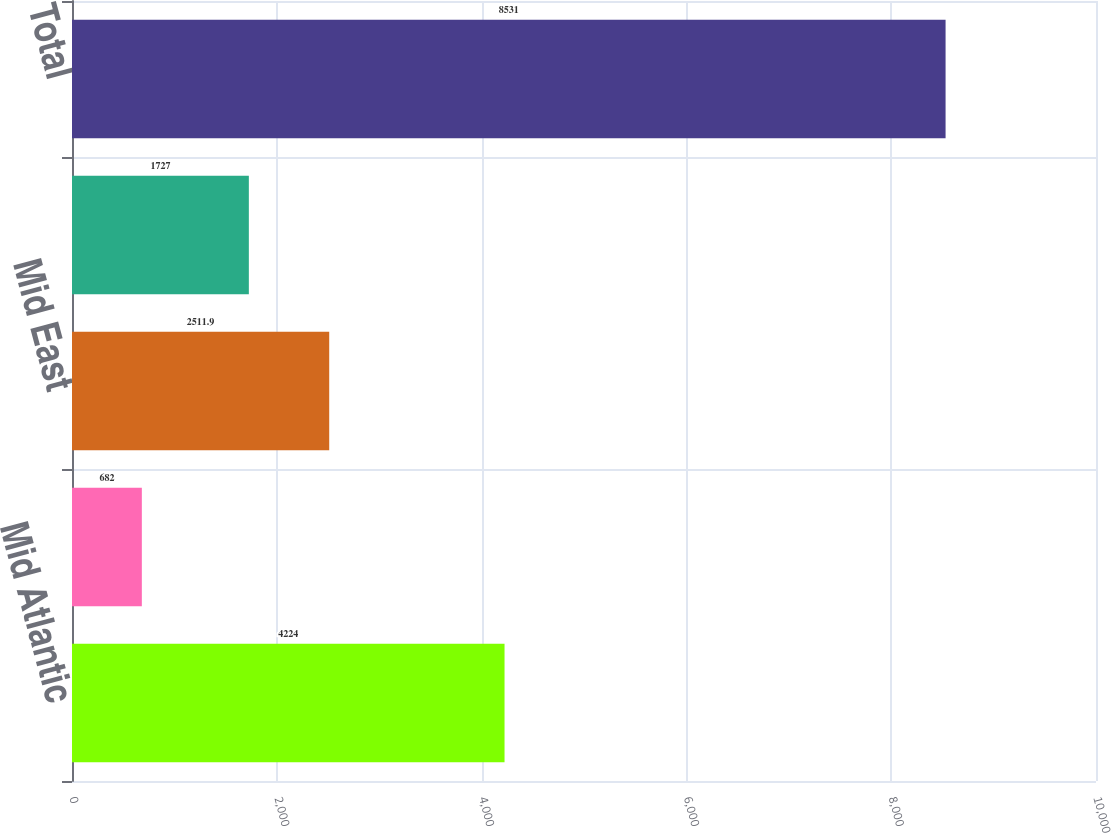Convert chart to OTSL. <chart><loc_0><loc_0><loc_500><loc_500><bar_chart><fcel>Mid Atlantic<fcel>North East<fcel>Mid East<fcel>South East<fcel>Total<nl><fcel>4224<fcel>682<fcel>2511.9<fcel>1727<fcel>8531<nl></chart> 